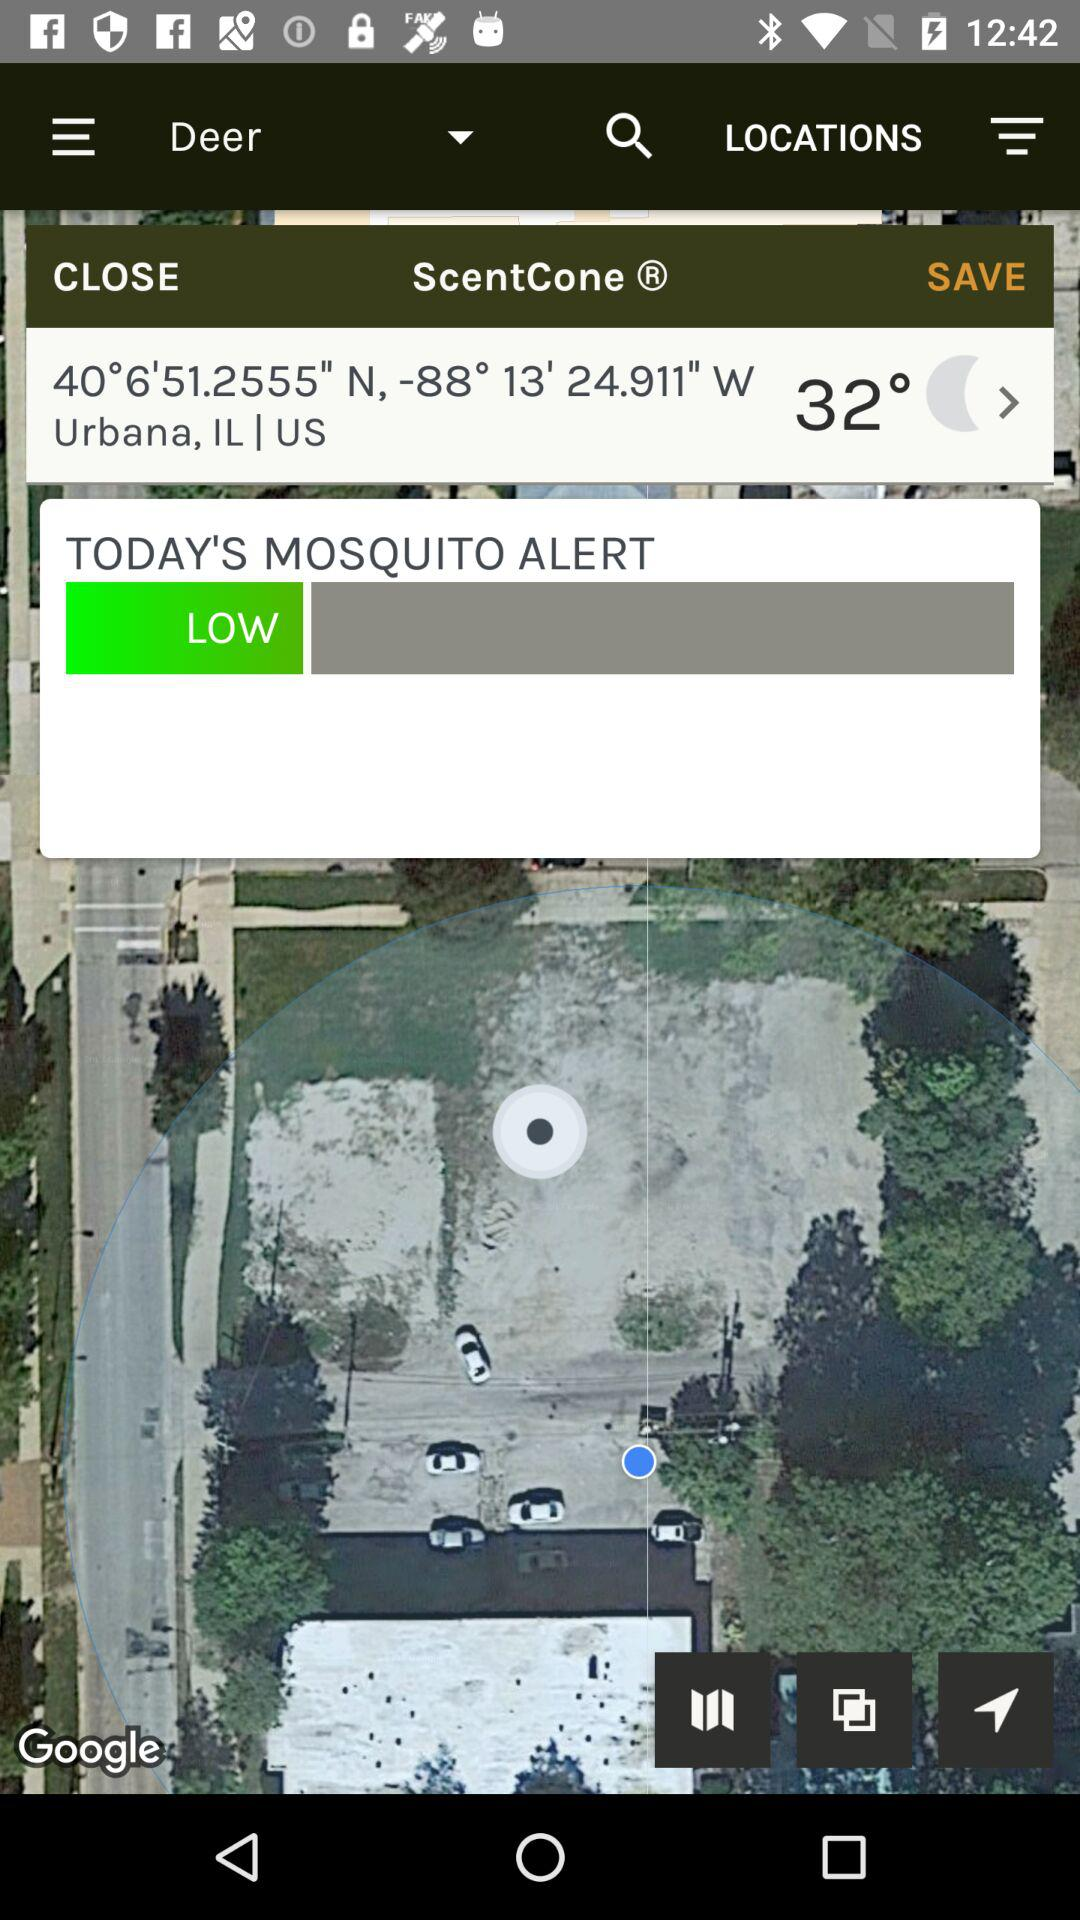What is the location? The location is Urbana, IL, US. 